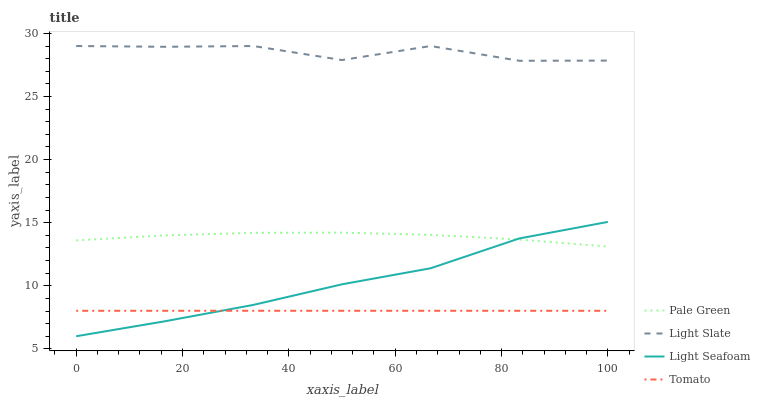Does Tomato have the minimum area under the curve?
Answer yes or no. Yes. Does Light Slate have the maximum area under the curve?
Answer yes or no. Yes. Does Pale Green have the minimum area under the curve?
Answer yes or no. No. Does Pale Green have the maximum area under the curve?
Answer yes or no. No. Is Tomato the smoothest?
Answer yes or no. Yes. Is Light Slate the roughest?
Answer yes or no. Yes. Is Pale Green the smoothest?
Answer yes or no. No. Is Pale Green the roughest?
Answer yes or no. No. Does Tomato have the lowest value?
Answer yes or no. No. Does Light Slate have the highest value?
Answer yes or no. Yes. Does Pale Green have the highest value?
Answer yes or no. No. Is Tomato less than Light Slate?
Answer yes or no. Yes. Is Light Slate greater than Tomato?
Answer yes or no. Yes. Does Tomato intersect Light Slate?
Answer yes or no. No. 